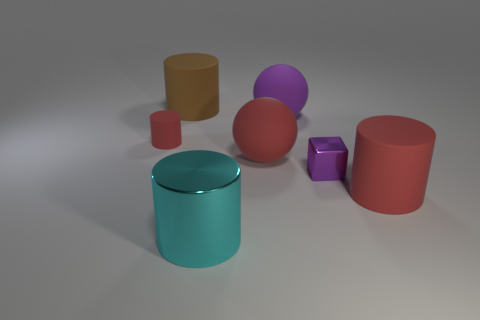Subtract 1 cylinders. How many cylinders are left? 3 Add 3 small metal cubes. How many objects exist? 10 Subtract all cubes. How many objects are left? 6 Subtract all large metallic things. Subtract all tiny red rubber cylinders. How many objects are left? 5 Add 6 large red rubber spheres. How many large red rubber spheres are left? 7 Add 5 red matte things. How many red matte things exist? 8 Subtract 1 purple cubes. How many objects are left? 6 